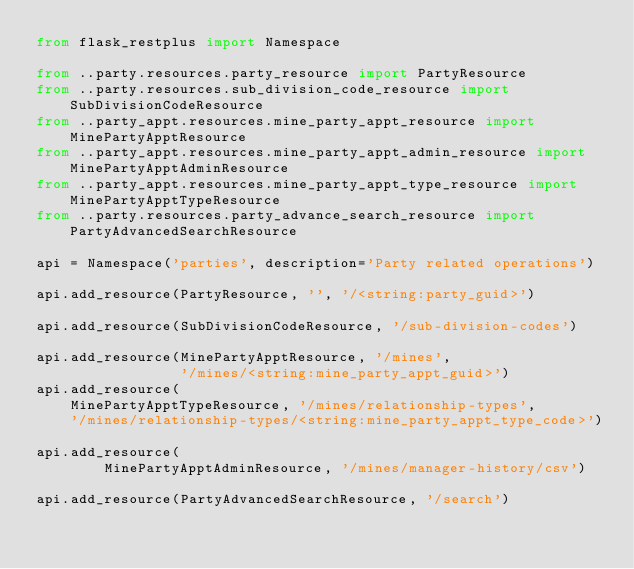Convert code to text. <code><loc_0><loc_0><loc_500><loc_500><_Python_>from flask_restplus import Namespace

from ..party.resources.party_resource import PartyResource
from ..party.resources.sub_division_code_resource import SubDivisionCodeResource
from ..party_appt.resources.mine_party_appt_resource import MinePartyApptResource
from ..party_appt.resources.mine_party_appt_admin_resource import MinePartyApptAdminResource
from ..party_appt.resources.mine_party_appt_type_resource import MinePartyApptTypeResource
from ..party.resources.party_advance_search_resource import PartyAdvancedSearchResource

api = Namespace('parties', description='Party related operations')

api.add_resource(PartyResource, '', '/<string:party_guid>')

api.add_resource(SubDivisionCodeResource, '/sub-division-codes')

api.add_resource(MinePartyApptResource, '/mines',
                 '/mines/<string:mine_party_appt_guid>')
api.add_resource(
    MinePartyApptTypeResource, '/mines/relationship-types',
    '/mines/relationship-types/<string:mine_party_appt_type_code>')

api.add_resource(
        MinePartyApptAdminResource, '/mines/manager-history/csv')

api.add_resource(PartyAdvancedSearchResource, '/search')
</code> 